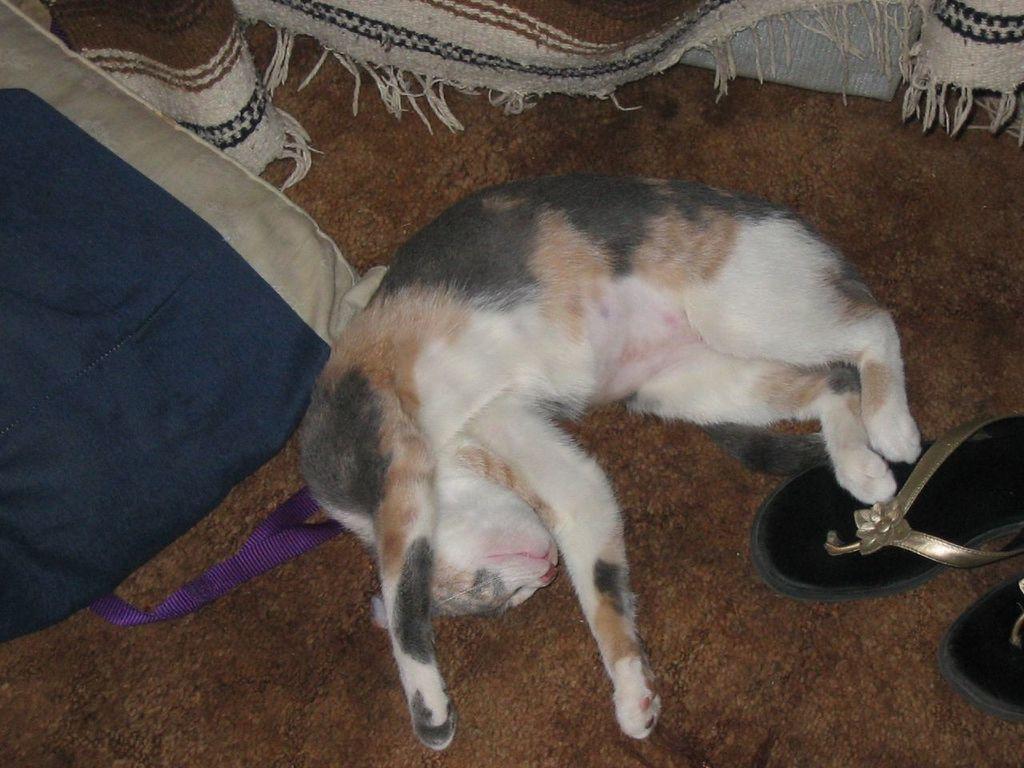How would you summarize this image in a sentence or two? In the center of the image we can see foot wears, one pillow, violet color belt and one cat, which is brown, white and black color. In the background we can see one blanket and one white color object. 